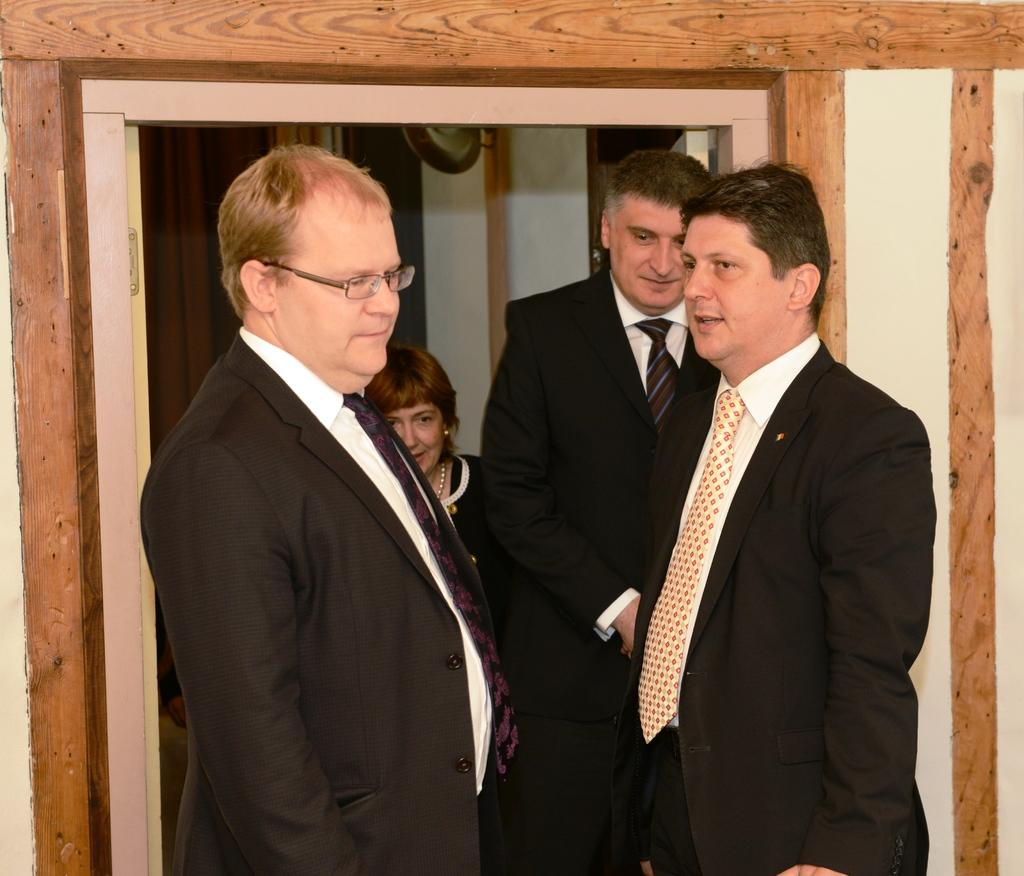Where was the image taken? The image is taken indoors. What can be seen in the background of the image? There is a wall in the background of the image. Who is present in the image? There is a woman and three men in the image. What are the men wearing? The men are wearing suits, ties, and shirts. How many bears are visible in the image? There are no bears present in the image. What is the limit of the woman's interest in the men's attire? The image does not provide information about the woman's interest in the men's attire, so we cannot determine a limit. 